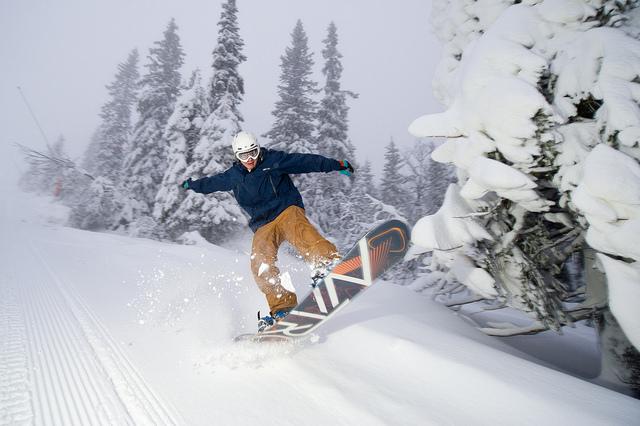Is the man moving at a fast rate down the mountain?
Keep it brief. Yes. Is the man snowboarding?
Concise answer only. Yes. How is the man standing?
Be succinct. Snowboard. 